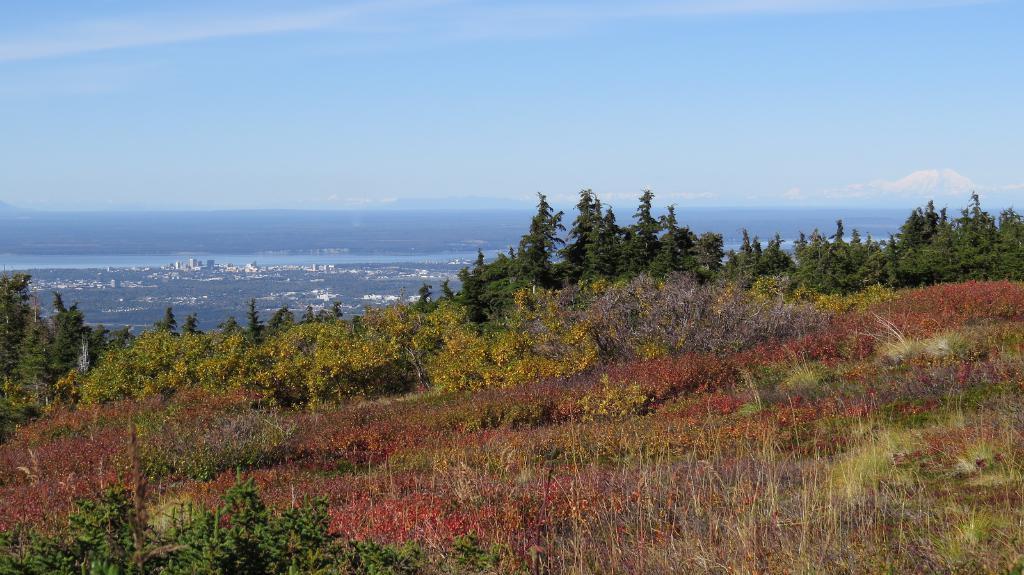Could you give a brief overview of what you see in this image? In this picture we can see trees on the ground and in the background we can see buildings, water and sky with clouds. 